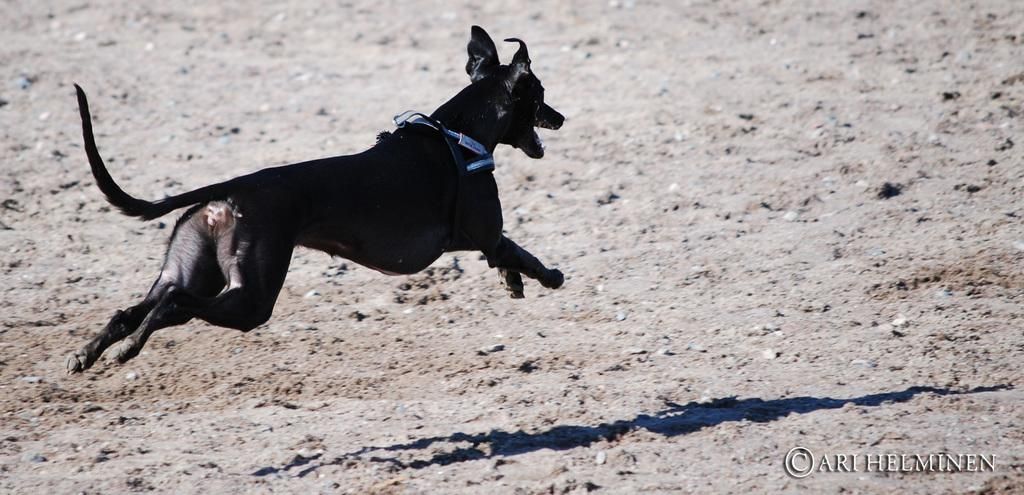What animal is present in the image? There is a dog in the image. What is the color of the dog? The dog is black in color. What is the dog doing in the image? The dog is running. Can you describe the dog's position in the image? The dog is in the air. What type of surface is visible in the image? There is a round surface in the image. What is visible at the bottom of the image? The ground is visible at the bottom of the image. What type of marble can be seen in the alley where the dog is running? There is no marble or alley present in the image; it features a dog running in the air above a round surface and the ground. 